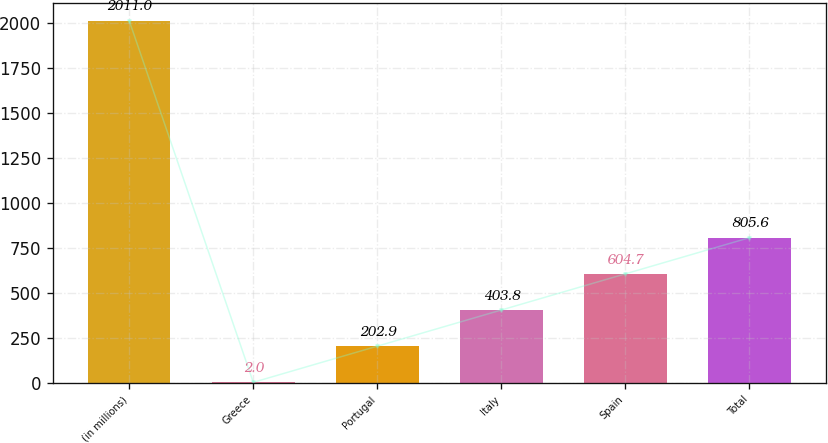Convert chart. <chart><loc_0><loc_0><loc_500><loc_500><bar_chart><fcel>(in millions)<fcel>Greece<fcel>Portugal<fcel>Italy<fcel>Spain<fcel>Total<nl><fcel>2011<fcel>2<fcel>202.9<fcel>403.8<fcel>604.7<fcel>805.6<nl></chart> 